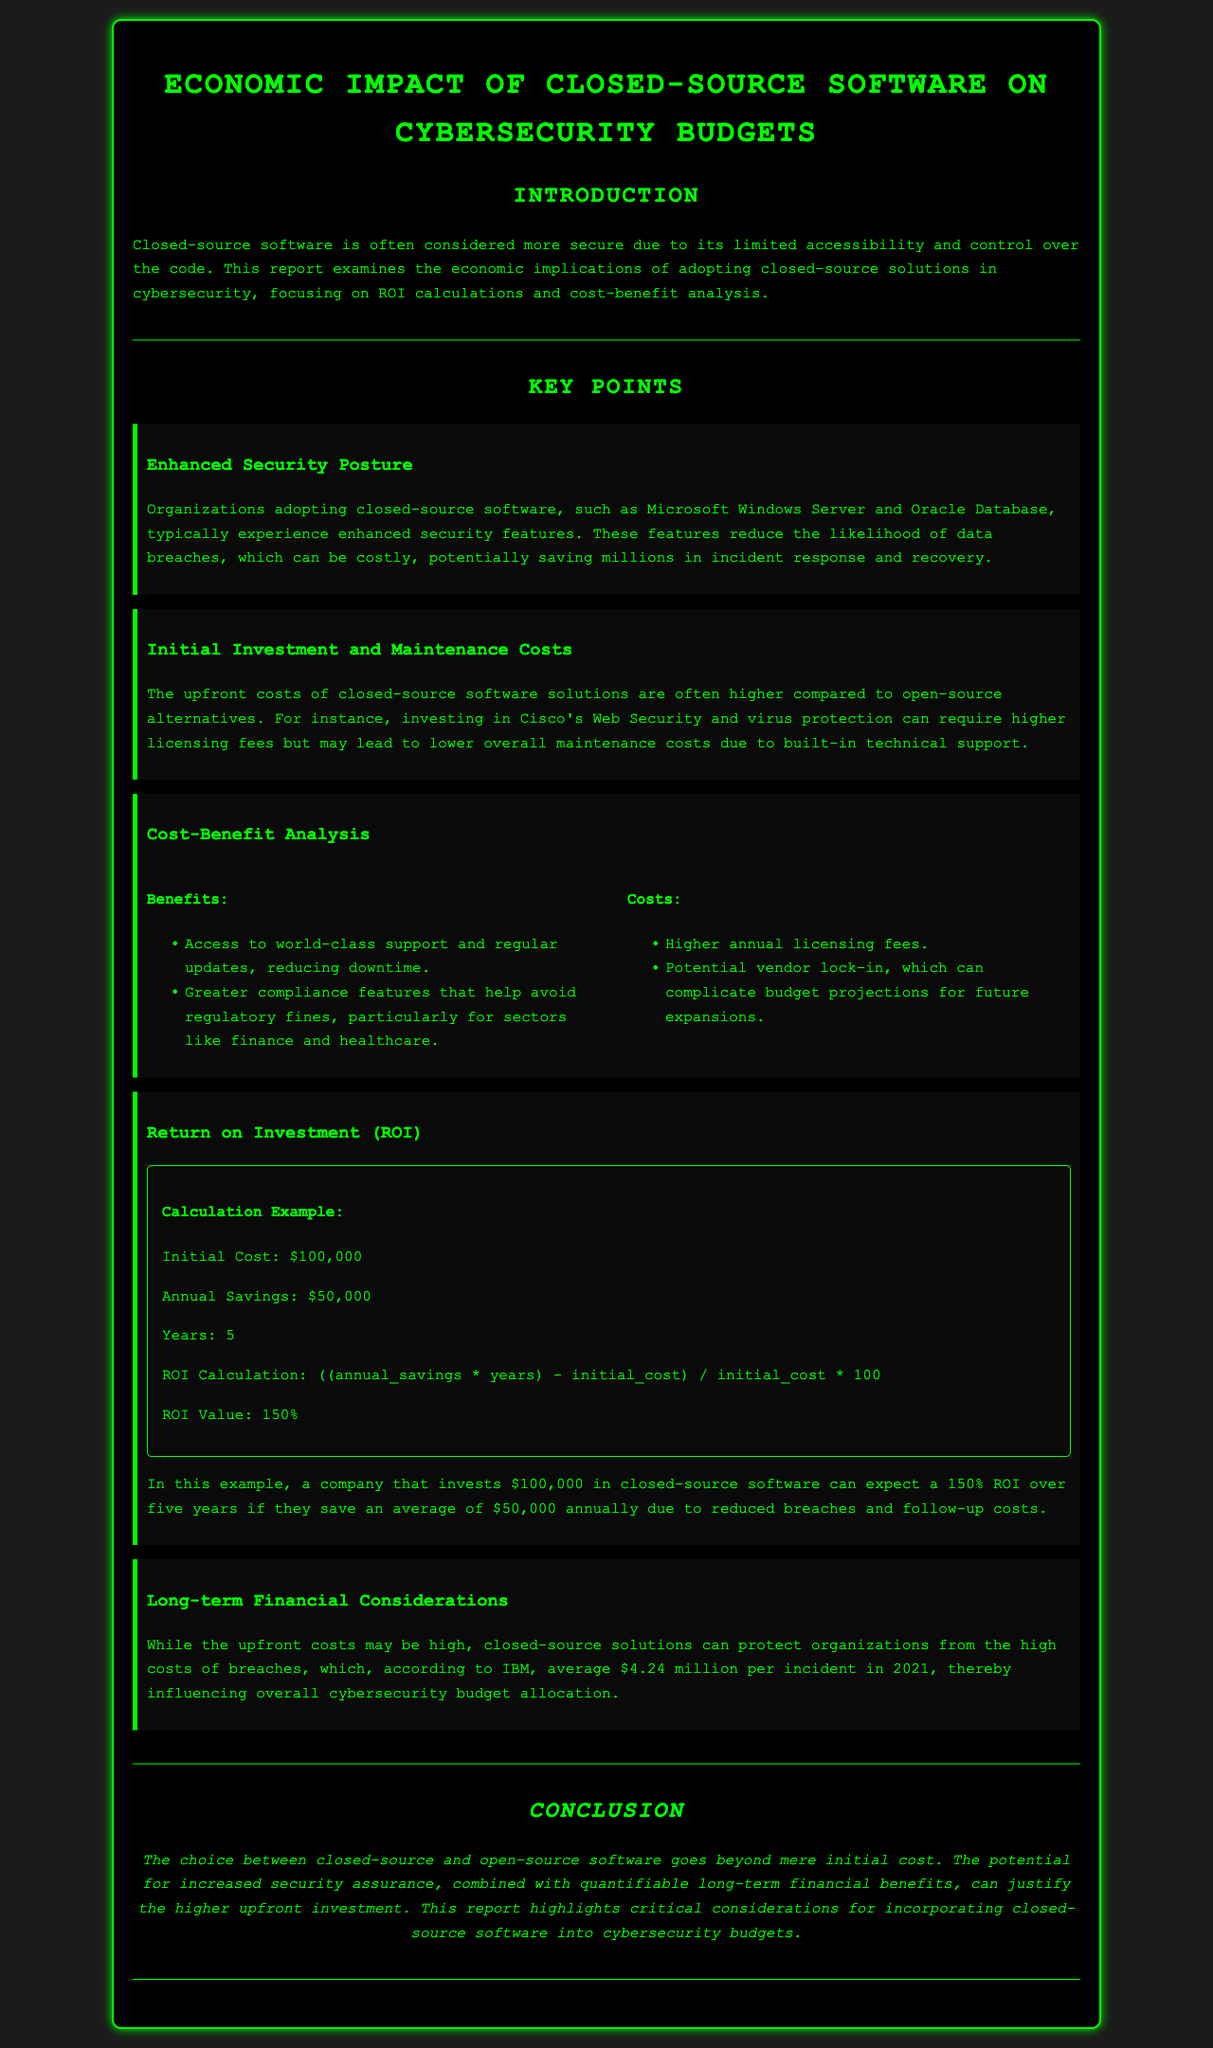What is the title of the report? The title is stated in the document header, summarizing the focus of the report.
Answer: Economic Impact of Closed-Source Software on Cybersecurity Budgets What is the acronym for Return on Investment? The acronym is used throughout financial documents to denote a key performance metric.
Answer: ROI What is the initial cost in the ROI calculation example? The initial cost figure is clearly mentioned in the ROI example section.
Answer: $100,000 What are the two software types mentioned in enhanced security posture? Specific software types are referenced to illustrate the concept of enhanced security.
Answer: Microsoft Windows Server and Oracle Database What is the potential average cost of a data breach mentioned? The document provides a figure based on industry averages, reflecting on cybersecurity costs.
Answer: $4.24 million What is one benefit of closed-source software mentioned in the cost-benefit analysis? The report lists specific advantages associated with closed-source solutions.
Answer: Access to world-class support What is one cost associated with closed-source software? The document outlines various financial concerns regarding closed-source options.
Answer: Higher annual licensing fees What is the ROI value calculated over five years? The ROI value is provided to give a quantitative measure of potential savings.
Answer: 150% What is stated as a common upfront cost consideration when choosing closed-source software? The report highlights financial implications for organizations regarding their software choices.
Answer: Higher upfront costs 